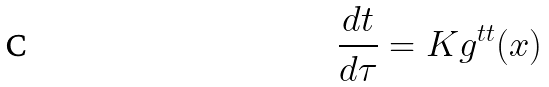<formula> <loc_0><loc_0><loc_500><loc_500>\frac { d t } { d \tau } = K g ^ { t t } ( x )</formula> 